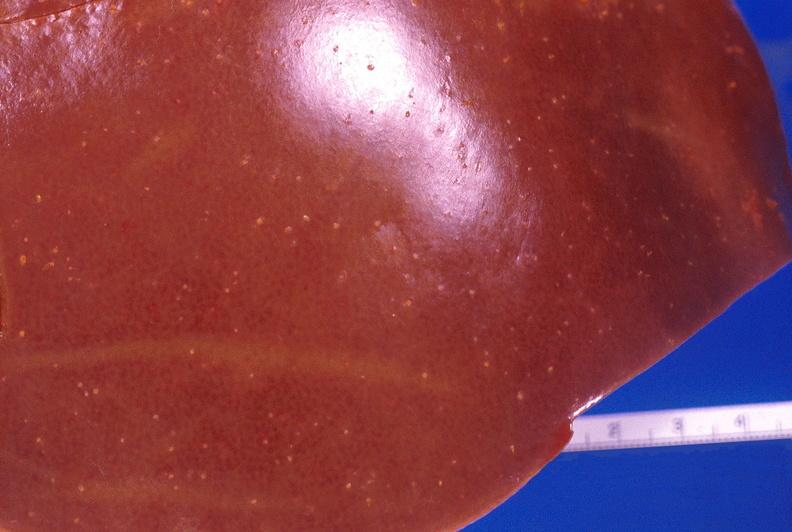what does this image show?
Answer the question using a single word or phrase. Liver 